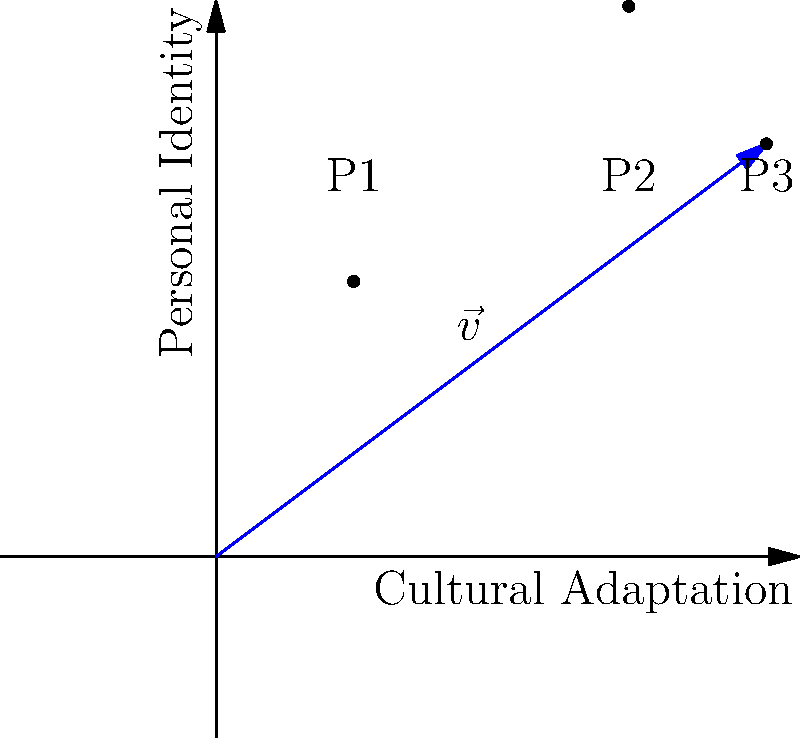In the graph, vector $\vec{v}$ represents personal growth in terms of cultural adaptation (x-axis) and maintaining personal identity (y-axis). If P1(1,2), P2(3,4), and P3(4,3) represent different stages of growth, what is the magnitude of $\vec{v}$ from the origin to P3? To find the magnitude of vector $\vec{v}$ from the origin to P3, we need to follow these steps:

1. Identify the coordinates of P3: (4,3)

2. Use the formula for the magnitude of a vector:
   $|\vec{v}| = \sqrt{x^2 + y^2}$

3. Substitute the values:
   $|\vec{v}| = \sqrt{4^2 + 3^2}$

4. Simplify:
   $|\vec{v}| = \sqrt{16 + 9}$
   $|\vec{v}| = \sqrt{25}$

5. Calculate the final result:
   $|\vec{v}| = 5$

The magnitude of vector $\vec{v}$ from the origin to P3 is 5 units.
Answer: 5 